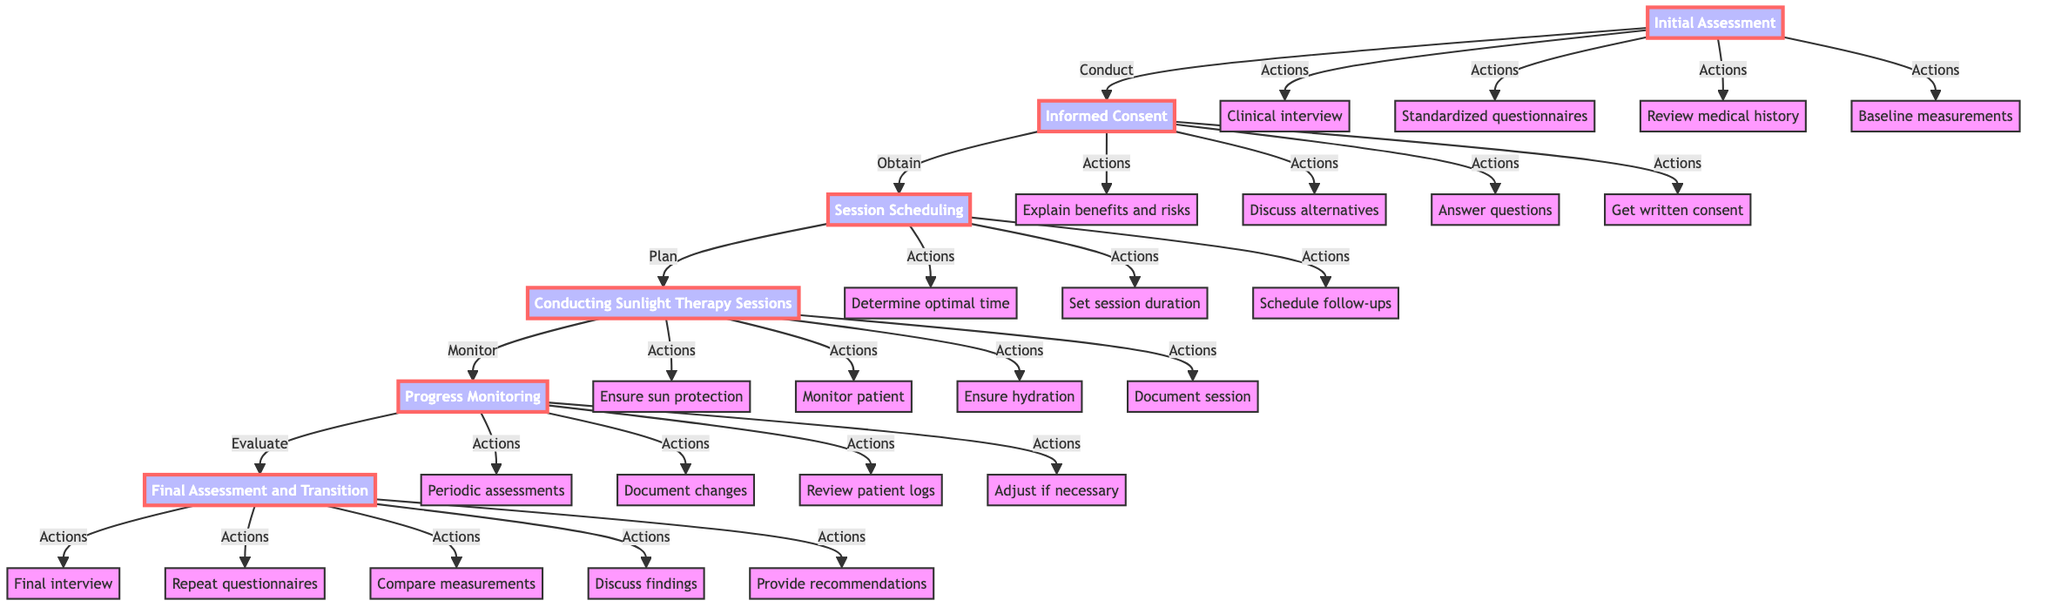What is the first step in the procedure? The first step in the procedure is the "Initial Assessment," as it is the first node in the flow chart.
Answer: Initial Assessment How many main steps are there in the procedure? By counting the main nodes in the diagram, there are six main steps represented in the flow chart.
Answer: 6 What action is associated with the "Informed Consent" step? The action associated with the "Informed Consent" step that frequently appears is to "Obtain written consent," as it is one of the specific actions outlined under this step.
Answer: Get written consent Which step requires monitoring the patient? The "Conducting Sunlight Therapy Sessions" step requires monitoring the patient, as it explicitly mentions patient monitoring during this step.
Answer: Conducting Sunlight Therapy Sessions What comes after the "Session Scheduling" step? After the "Session Scheduling" step, the next step, which is indicated by the arrow in the diagram, is "Conducting Sunlight Therapy Sessions."
Answer: Conducting Sunlight Therapy Sessions How many actions are specified for the "Progress Monitoring" step? The "Progress Monitoring" step lists four specific actions, as indicated by the four actions branching from this node.
Answer: 4 What is the last action taken in the process? The last action taken, as stated in the flow chart, is to "Provide recommendations for ongoing mental health management," which appears under the final assessment step.
Answer: Provide recommendations Which step involves repeating standardized mental health questionnaires? The step that involves repeating standardized mental health questionnaires is "Final Assessment and Transition," reflecting the evaluation phase of the therapy protocol.
Answer: Final Assessment and Transition What is done during the "Final Assessment and Transition" step? During the "Final Assessment and Transition," several evaluations are conducted, including performing a final clinical interview and comparing pre- and post-therapy measurements, among other actions.
Answer: Compare pre- and post-therapy measurements 